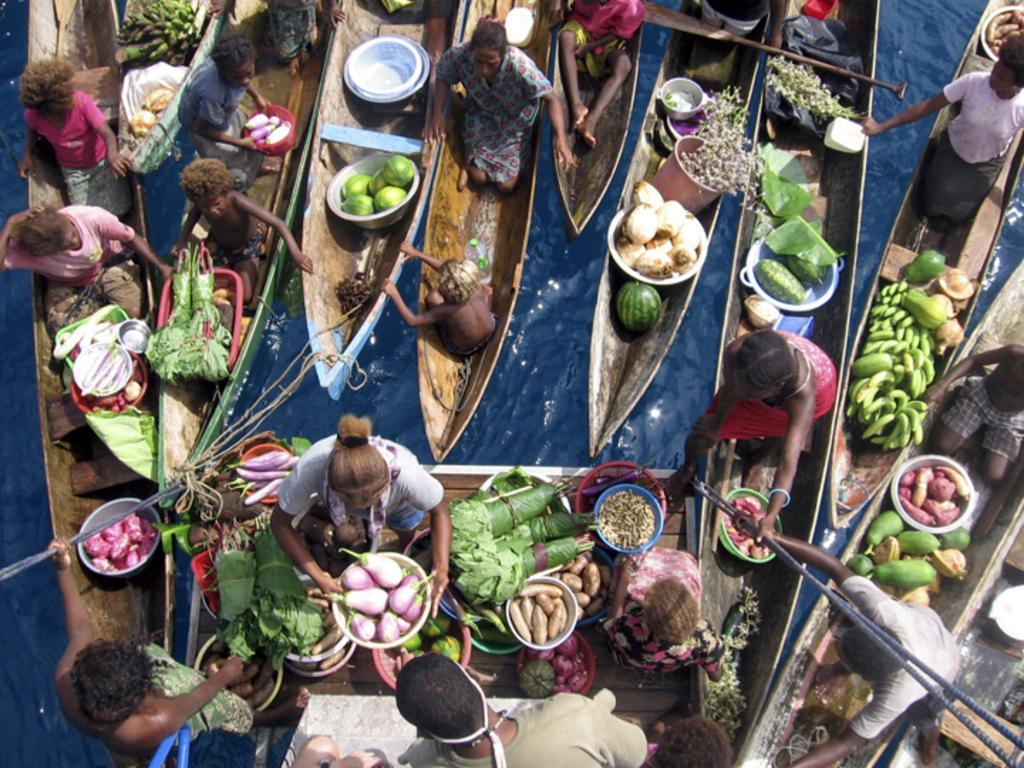What type of vehicles can be seen in the image? There are boats in the image. Who or what else is present in the image? There are people in the image. What type of food items are visible in the image? Vegetables such as brinjal, potato, and leafy vegetables are present in the image. What natural element is visible in the image? There is water visible in the image. What is the name of the queen who is sailing in one of the boats in the image? There is no queen present in the image, and the names of individuals cannot be determined from the image. 